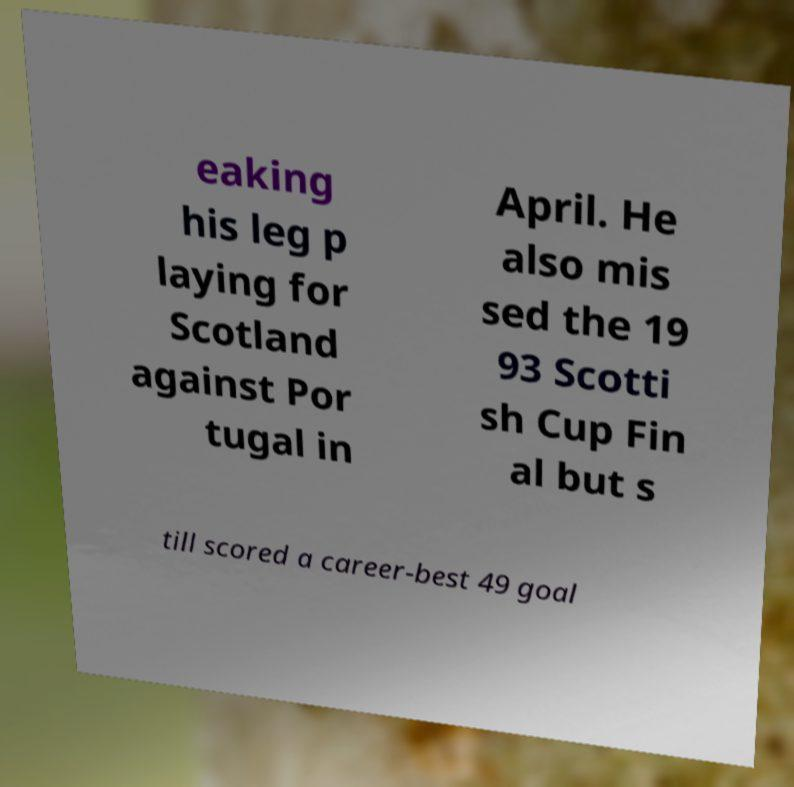Could you extract and type out the text from this image? eaking his leg p laying for Scotland against Por tugal in April. He also mis sed the 19 93 Scotti sh Cup Fin al but s till scored a career-best 49 goal 